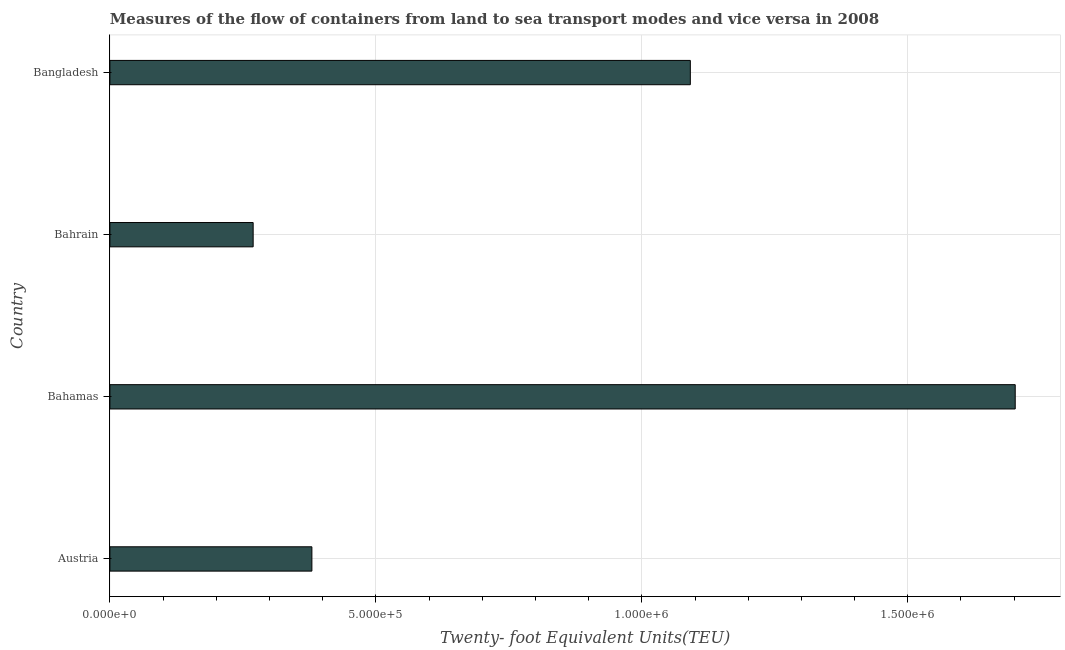Does the graph contain grids?
Keep it short and to the point. Yes. What is the title of the graph?
Offer a terse response. Measures of the flow of containers from land to sea transport modes and vice versa in 2008. What is the label or title of the X-axis?
Provide a short and direct response. Twenty- foot Equivalent Units(TEU). What is the label or title of the Y-axis?
Your answer should be compact. Country. What is the container port traffic in Bahrain?
Make the answer very short. 2.69e+05. Across all countries, what is the maximum container port traffic?
Your answer should be compact. 1.70e+06. Across all countries, what is the minimum container port traffic?
Provide a short and direct response. 2.69e+05. In which country was the container port traffic maximum?
Your answer should be very brief. Bahamas. In which country was the container port traffic minimum?
Ensure brevity in your answer.  Bahrain. What is the sum of the container port traffic?
Give a very brief answer. 3.44e+06. What is the difference between the container port traffic in Austria and Bangladesh?
Provide a short and direct response. -7.11e+05. What is the average container port traffic per country?
Your answer should be compact. 8.61e+05. What is the median container port traffic?
Keep it short and to the point. 7.35e+05. In how many countries, is the container port traffic greater than 200000 TEU?
Offer a terse response. 4. What is the ratio of the container port traffic in Austria to that in Bangladesh?
Offer a very short reply. 0.35. Is the container port traffic in Austria less than that in Bahrain?
Keep it short and to the point. No. What is the difference between the highest and the second highest container port traffic?
Offer a very short reply. 6.11e+05. Is the sum of the container port traffic in Austria and Bahrain greater than the maximum container port traffic across all countries?
Give a very brief answer. No. What is the difference between the highest and the lowest container port traffic?
Offer a terse response. 1.43e+06. Are the values on the major ticks of X-axis written in scientific E-notation?
Your answer should be compact. Yes. What is the Twenty- foot Equivalent Units(TEU) in Austria?
Provide a short and direct response. 3.80e+05. What is the Twenty- foot Equivalent Units(TEU) in Bahamas?
Your response must be concise. 1.70e+06. What is the Twenty- foot Equivalent Units(TEU) in Bahrain?
Provide a short and direct response. 2.69e+05. What is the Twenty- foot Equivalent Units(TEU) in Bangladesh?
Ensure brevity in your answer.  1.09e+06. What is the difference between the Twenty- foot Equivalent Units(TEU) in Austria and Bahamas?
Make the answer very short. -1.32e+06. What is the difference between the Twenty- foot Equivalent Units(TEU) in Austria and Bahrain?
Your answer should be compact. 1.10e+05. What is the difference between the Twenty- foot Equivalent Units(TEU) in Austria and Bangladesh?
Give a very brief answer. -7.11e+05. What is the difference between the Twenty- foot Equivalent Units(TEU) in Bahamas and Bahrain?
Offer a terse response. 1.43e+06. What is the difference between the Twenty- foot Equivalent Units(TEU) in Bahamas and Bangladesh?
Provide a short and direct response. 6.11e+05. What is the difference between the Twenty- foot Equivalent Units(TEU) in Bahrain and Bangladesh?
Provide a short and direct response. -8.22e+05. What is the ratio of the Twenty- foot Equivalent Units(TEU) in Austria to that in Bahamas?
Provide a short and direct response. 0.22. What is the ratio of the Twenty- foot Equivalent Units(TEU) in Austria to that in Bahrain?
Give a very brief answer. 1.41. What is the ratio of the Twenty- foot Equivalent Units(TEU) in Austria to that in Bangladesh?
Keep it short and to the point. 0.35. What is the ratio of the Twenty- foot Equivalent Units(TEU) in Bahamas to that in Bahrain?
Your answer should be very brief. 6.32. What is the ratio of the Twenty- foot Equivalent Units(TEU) in Bahamas to that in Bangladesh?
Keep it short and to the point. 1.56. What is the ratio of the Twenty- foot Equivalent Units(TEU) in Bahrain to that in Bangladesh?
Provide a short and direct response. 0.25. 